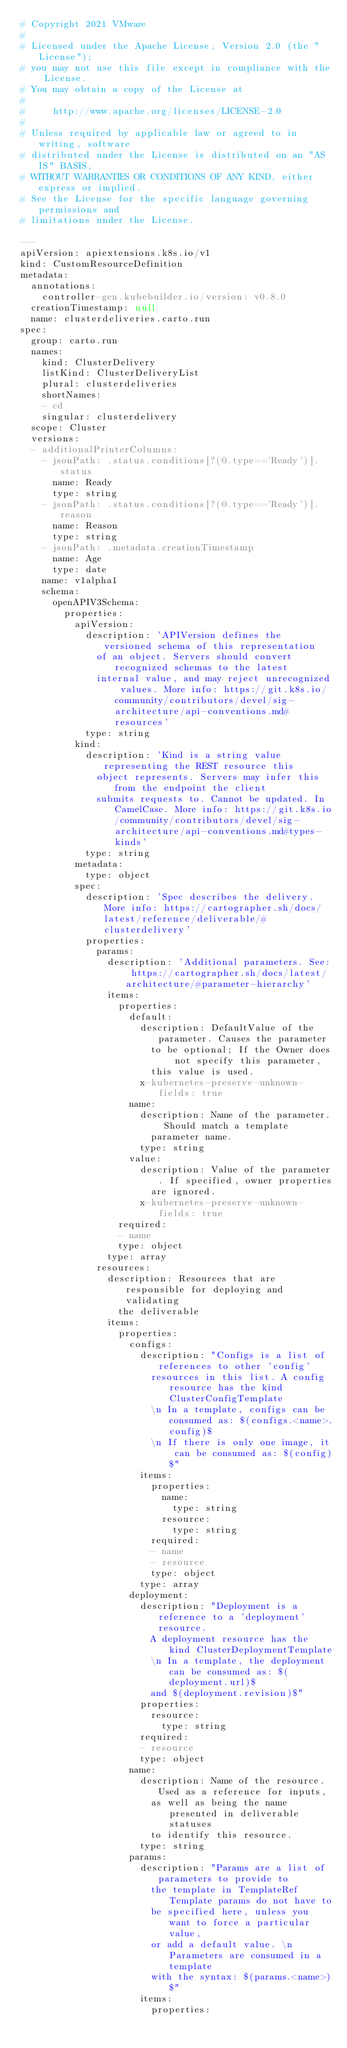<code> <loc_0><loc_0><loc_500><loc_500><_YAML_># Copyright 2021 VMware
#
# Licensed under the Apache License, Version 2.0 (the "License");
# you may not use this file except in compliance with the License.
# You may obtain a copy of the License at
#
#     http://www.apache.org/licenses/LICENSE-2.0
#
# Unless required by applicable law or agreed to in writing, software
# distributed under the License is distributed on an "AS IS" BASIS,
# WITHOUT WARRANTIES OR CONDITIONS OF ANY KIND, either express or implied.
# See the License for the specific language governing permissions and
# limitations under the License.

---
apiVersion: apiextensions.k8s.io/v1
kind: CustomResourceDefinition
metadata:
  annotations:
    controller-gen.kubebuilder.io/version: v0.8.0
  creationTimestamp: null
  name: clusterdeliveries.carto.run
spec:
  group: carto.run
  names:
    kind: ClusterDelivery
    listKind: ClusterDeliveryList
    plural: clusterdeliveries
    shortNames:
    - cd
    singular: clusterdelivery
  scope: Cluster
  versions:
  - additionalPrinterColumns:
    - jsonPath: .status.conditions[?(@.type=='Ready')].status
      name: Ready
      type: string
    - jsonPath: .status.conditions[?(@.type=='Ready')].reason
      name: Reason
      type: string
    - jsonPath: .metadata.creationTimestamp
      name: Age
      type: date
    name: v1alpha1
    schema:
      openAPIV3Schema:
        properties:
          apiVersion:
            description: 'APIVersion defines the versioned schema of this representation
              of an object. Servers should convert recognized schemas to the latest
              internal value, and may reject unrecognized values. More info: https://git.k8s.io/community/contributors/devel/sig-architecture/api-conventions.md#resources'
            type: string
          kind:
            description: 'Kind is a string value representing the REST resource this
              object represents. Servers may infer this from the endpoint the client
              submits requests to. Cannot be updated. In CamelCase. More info: https://git.k8s.io/community/contributors/devel/sig-architecture/api-conventions.md#types-kinds'
            type: string
          metadata:
            type: object
          spec:
            description: 'Spec describes the delivery. More info: https://cartographer.sh/docs/latest/reference/deliverable/#clusterdelivery'
            properties:
              params:
                description: 'Additional parameters. See: https://cartographer.sh/docs/latest/architecture/#parameter-hierarchy'
                items:
                  properties:
                    default:
                      description: DefaultValue of the parameter. Causes the parameter
                        to be optional; If the Owner does not specify this parameter,
                        this value is used.
                      x-kubernetes-preserve-unknown-fields: true
                    name:
                      description: Name of the parameter. Should match a template
                        parameter name.
                      type: string
                    value:
                      description: Value of the parameter. If specified, owner properties
                        are ignored.
                      x-kubernetes-preserve-unknown-fields: true
                  required:
                  - name
                  type: object
                type: array
              resources:
                description: Resources that are responsible for deploying and validating
                  the deliverable
                items:
                  properties:
                    configs:
                      description: "Configs is a list of references to other 'config'
                        resources in this list. A config resource has the kind ClusterConfigTemplate
                        \n In a template, configs can be consumed as: $(configs.<name>.config)$
                        \n If there is only one image, it can be consumed as: $(config)$"
                      items:
                        properties:
                          name:
                            type: string
                          resource:
                            type: string
                        required:
                        - name
                        - resource
                        type: object
                      type: array
                    deployment:
                      description: "Deployment is a reference to a 'deployment' resource.
                        A deployment resource has the kind ClusterDeploymentTemplate
                        \n In a template, the deployment can be consumed as: $(deployment.url)$
                        and $(deployment.revision)$"
                      properties:
                        resource:
                          type: string
                      required:
                      - resource
                      type: object
                    name:
                      description: Name of the resource. Used as a reference for inputs,
                        as well as being the name presented in deliverable statuses
                        to identify this resource.
                      type: string
                    params:
                      description: "Params are a list of parameters to provide to
                        the template in TemplateRef Template params do not have to
                        be specified here, unless you want to force a particular value,
                        or add a default value. \n Parameters are consumed in a template
                        with the syntax: $(params.<name>)$"
                      items:
                        properties:</code> 